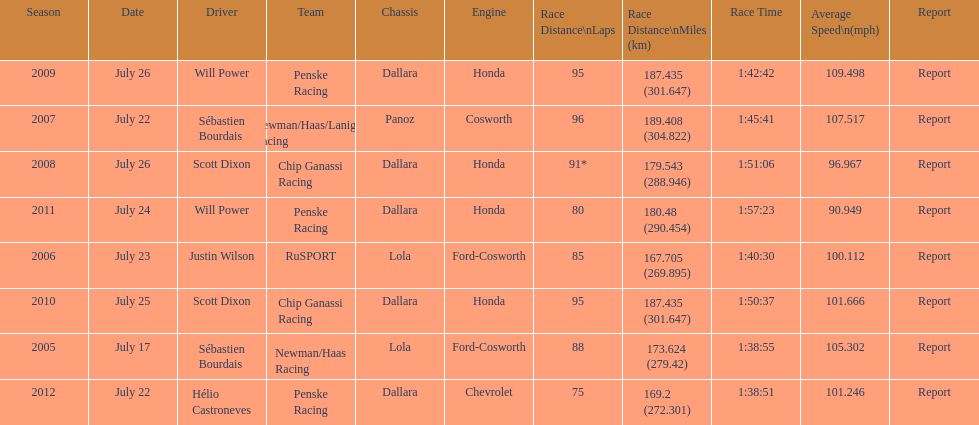Which team won the champ car world series the year before rusport? Newman/Haas Racing. 